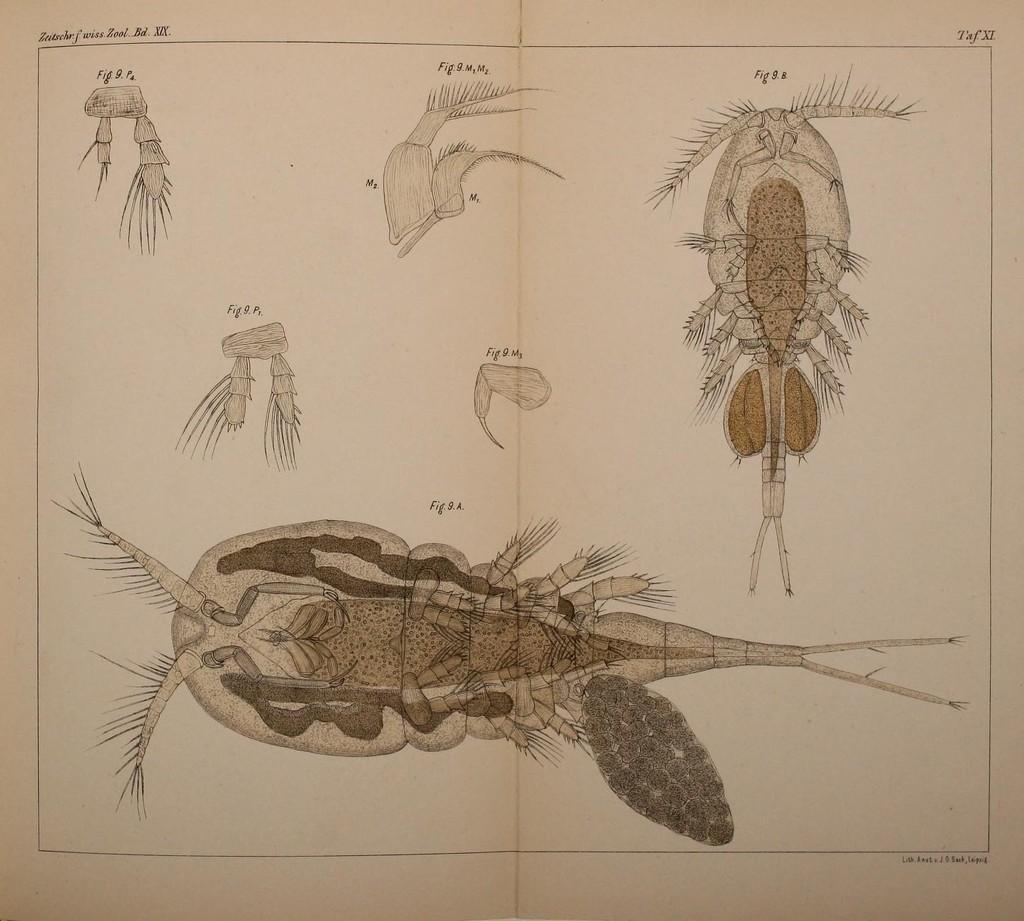Describe this image in one or two sentences. This is a book. On the book we can see the sketch of an internal structure and parts of the insects. In the background of the image we can see the text. 